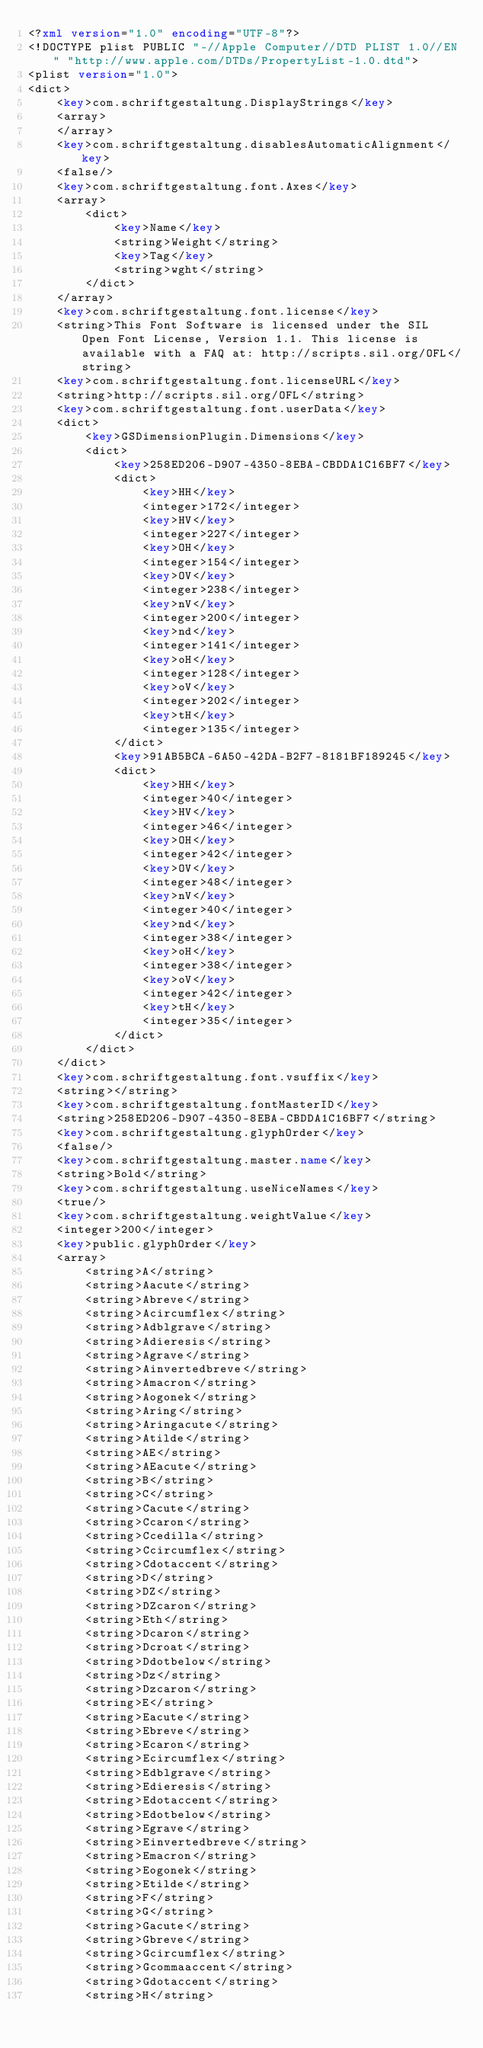<code> <loc_0><loc_0><loc_500><loc_500><_XML_><?xml version="1.0" encoding="UTF-8"?>
<!DOCTYPE plist PUBLIC "-//Apple Computer//DTD PLIST 1.0//EN" "http://www.apple.com/DTDs/PropertyList-1.0.dtd">
<plist version="1.0">
<dict>
	<key>com.schriftgestaltung.DisplayStrings</key>
	<array>
	</array>
	<key>com.schriftgestaltung.disablesAutomaticAlignment</key>
	<false/>
	<key>com.schriftgestaltung.font.Axes</key>
	<array>
		<dict>
			<key>Name</key>
			<string>Weight</string>
			<key>Tag</key>
			<string>wght</string>
		</dict>
	</array>
	<key>com.schriftgestaltung.font.license</key>
	<string>This Font Software is licensed under the SIL Open Font License, Version 1.1. This license is available with a FAQ at: http://scripts.sil.org/OFL</string>
	<key>com.schriftgestaltung.font.licenseURL</key>
	<string>http://scripts.sil.org/OFL</string>
	<key>com.schriftgestaltung.font.userData</key>
	<dict>
		<key>GSDimensionPlugin.Dimensions</key>
		<dict>
			<key>258ED206-D907-4350-8EBA-CBDDA1C16BF7</key>
			<dict>
				<key>HH</key>
				<integer>172</integer>
				<key>HV</key>
				<integer>227</integer>
				<key>OH</key>
				<integer>154</integer>
				<key>OV</key>
				<integer>238</integer>
				<key>nV</key>
				<integer>200</integer>
				<key>nd</key>
				<integer>141</integer>
				<key>oH</key>
				<integer>128</integer>
				<key>oV</key>
				<integer>202</integer>
				<key>tH</key>
				<integer>135</integer>
			</dict>
			<key>91AB5BCA-6A50-42DA-B2F7-8181BF189245</key>
			<dict>
				<key>HH</key>
				<integer>40</integer>
				<key>HV</key>
				<integer>46</integer>
				<key>OH</key>
				<integer>42</integer>
				<key>OV</key>
				<integer>48</integer>
				<key>nV</key>
				<integer>40</integer>
				<key>nd</key>
				<integer>38</integer>
				<key>oH</key>
				<integer>38</integer>
				<key>oV</key>
				<integer>42</integer>
				<key>tH</key>
				<integer>35</integer>
			</dict>
		</dict>
	</dict>
	<key>com.schriftgestaltung.font.vsuffix</key>
	<string></string>
	<key>com.schriftgestaltung.fontMasterID</key>
	<string>258ED206-D907-4350-8EBA-CBDDA1C16BF7</string>
	<key>com.schriftgestaltung.glyphOrder</key>
	<false/>
	<key>com.schriftgestaltung.master.name</key>
	<string>Bold</string>
	<key>com.schriftgestaltung.useNiceNames</key>
	<true/>
	<key>com.schriftgestaltung.weightValue</key>
	<integer>200</integer>
	<key>public.glyphOrder</key>
	<array>
		<string>A</string>
		<string>Aacute</string>
		<string>Abreve</string>
		<string>Acircumflex</string>
		<string>Adblgrave</string>
		<string>Adieresis</string>
		<string>Agrave</string>
		<string>Ainvertedbreve</string>
		<string>Amacron</string>
		<string>Aogonek</string>
		<string>Aring</string>
		<string>Aringacute</string>
		<string>Atilde</string>
		<string>AE</string>
		<string>AEacute</string>
		<string>B</string>
		<string>C</string>
		<string>Cacute</string>
		<string>Ccaron</string>
		<string>Ccedilla</string>
		<string>Ccircumflex</string>
		<string>Cdotaccent</string>
		<string>D</string>
		<string>DZ</string>
		<string>DZcaron</string>
		<string>Eth</string>
		<string>Dcaron</string>
		<string>Dcroat</string>
		<string>Ddotbelow</string>
		<string>Dz</string>
		<string>Dzcaron</string>
		<string>E</string>
		<string>Eacute</string>
		<string>Ebreve</string>
		<string>Ecaron</string>
		<string>Ecircumflex</string>
		<string>Edblgrave</string>
		<string>Edieresis</string>
		<string>Edotaccent</string>
		<string>Edotbelow</string>
		<string>Egrave</string>
		<string>Einvertedbreve</string>
		<string>Emacron</string>
		<string>Eogonek</string>
		<string>Etilde</string>
		<string>F</string>
		<string>G</string>
		<string>Gacute</string>
		<string>Gbreve</string>
		<string>Gcircumflex</string>
		<string>Gcommaaccent</string>
		<string>Gdotaccent</string>
		<string>H</string></code> 